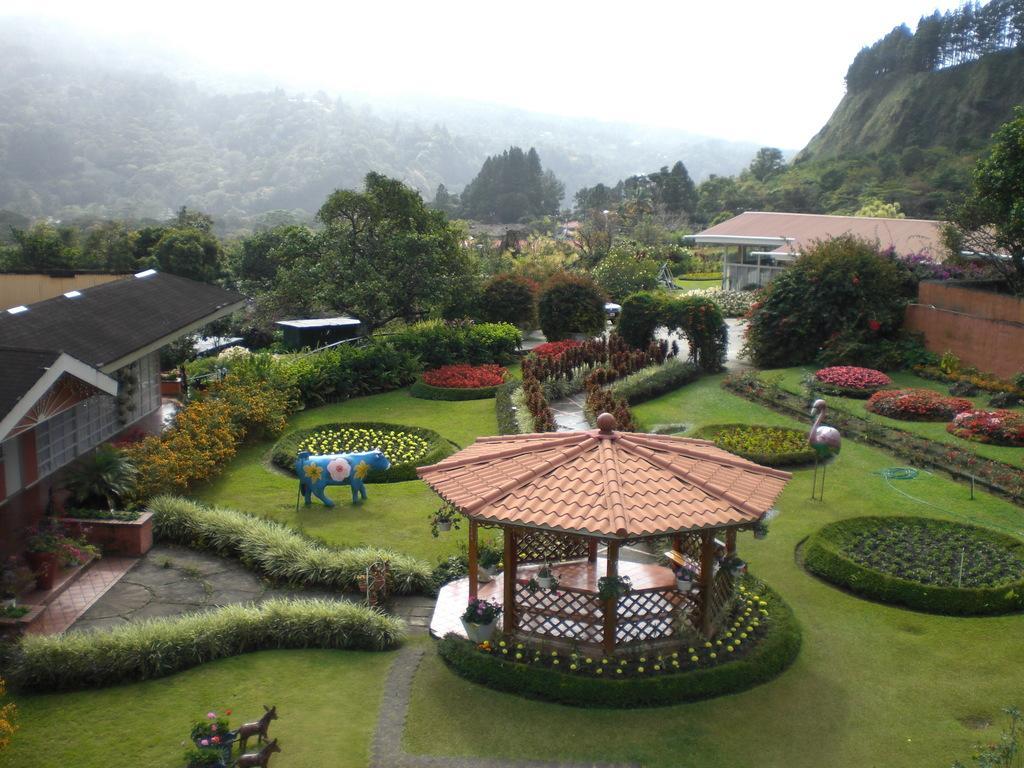Describe this image in one or two sentences. In this picture we can see a shed, house plants, statues, trees, houses, flowers, grass, paths, mountains and in the background we can see the sky. 